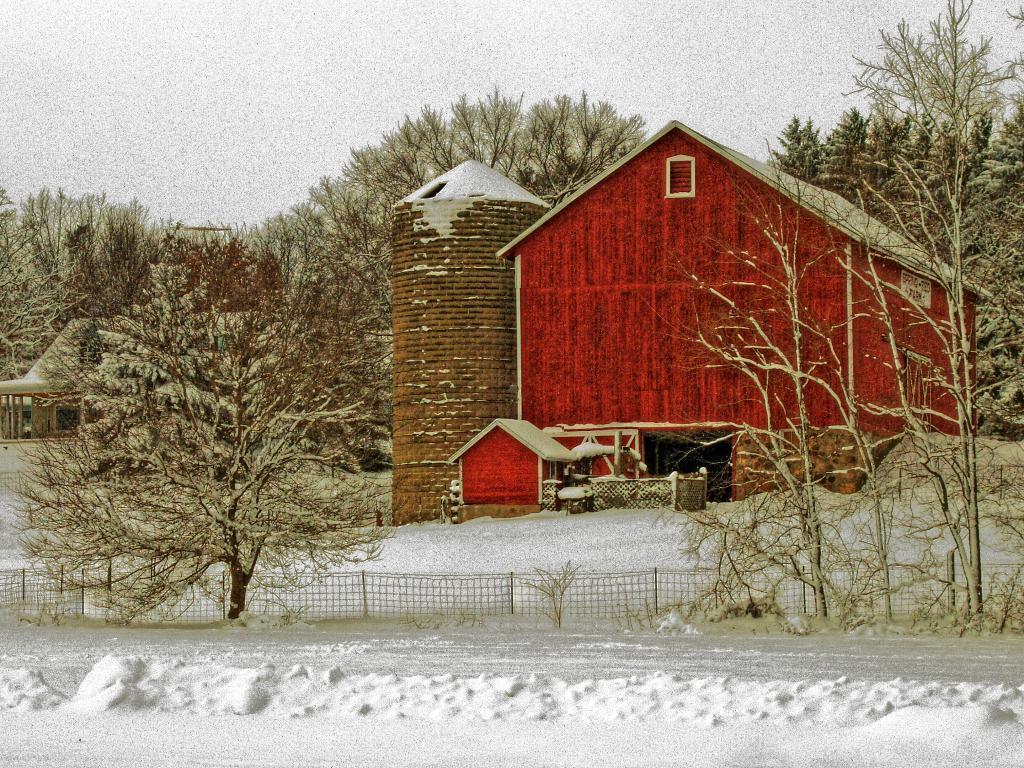Could you give a brief overview of what you see in this image? In this image we can see a red color house, there are some trees, fence and the snow, in the background we can see the sky. 